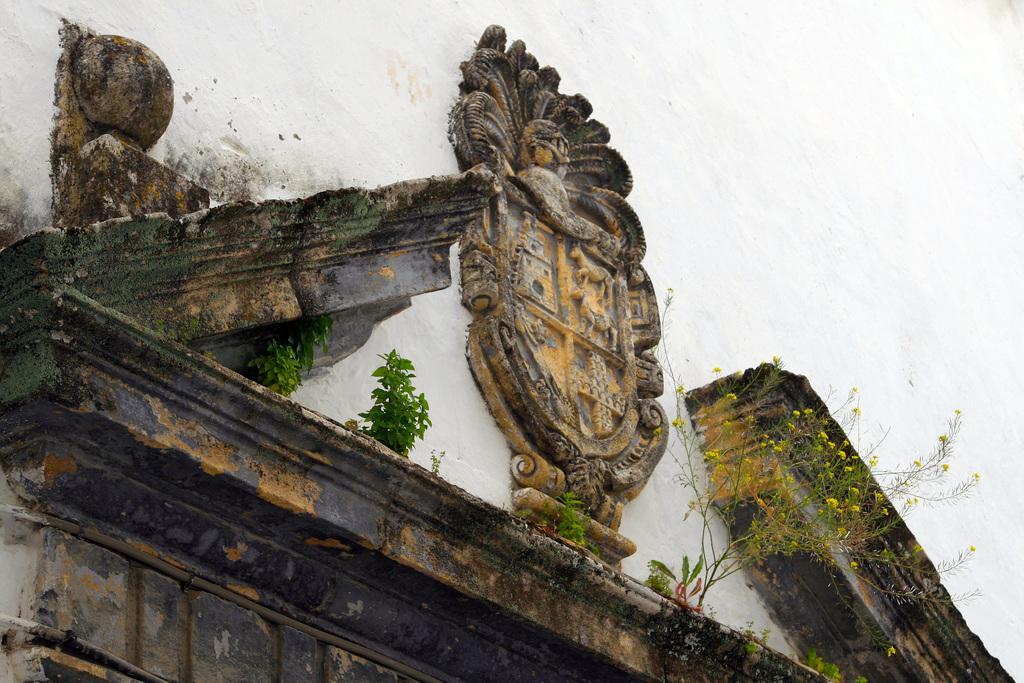In one or two sentences, can you explain what this image depicts? In this image there is a wall. There are sculptures on the wall. There are plants and algae on the wall. 